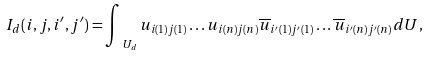Convert formula to latex. <formula><loc_0><loc_0><loc_500><loc_500>I _ { d } ( i , j , i ^ { \prime } , j ^ { \prime } ) = \int _ { \ U _ { d } } u _ { i ( 1 ) j ( 1 ) } \dots u _ { i ( n ) j ( n ) } \overline { u } _ { i ^ { \prime } ( 1 ) j ^ { \prime } ( 1 ) } \dots \overline { u } _ { i ^ { \prime } ( n ) j ^ { \prime } ( n ) } d U ,</formula> 